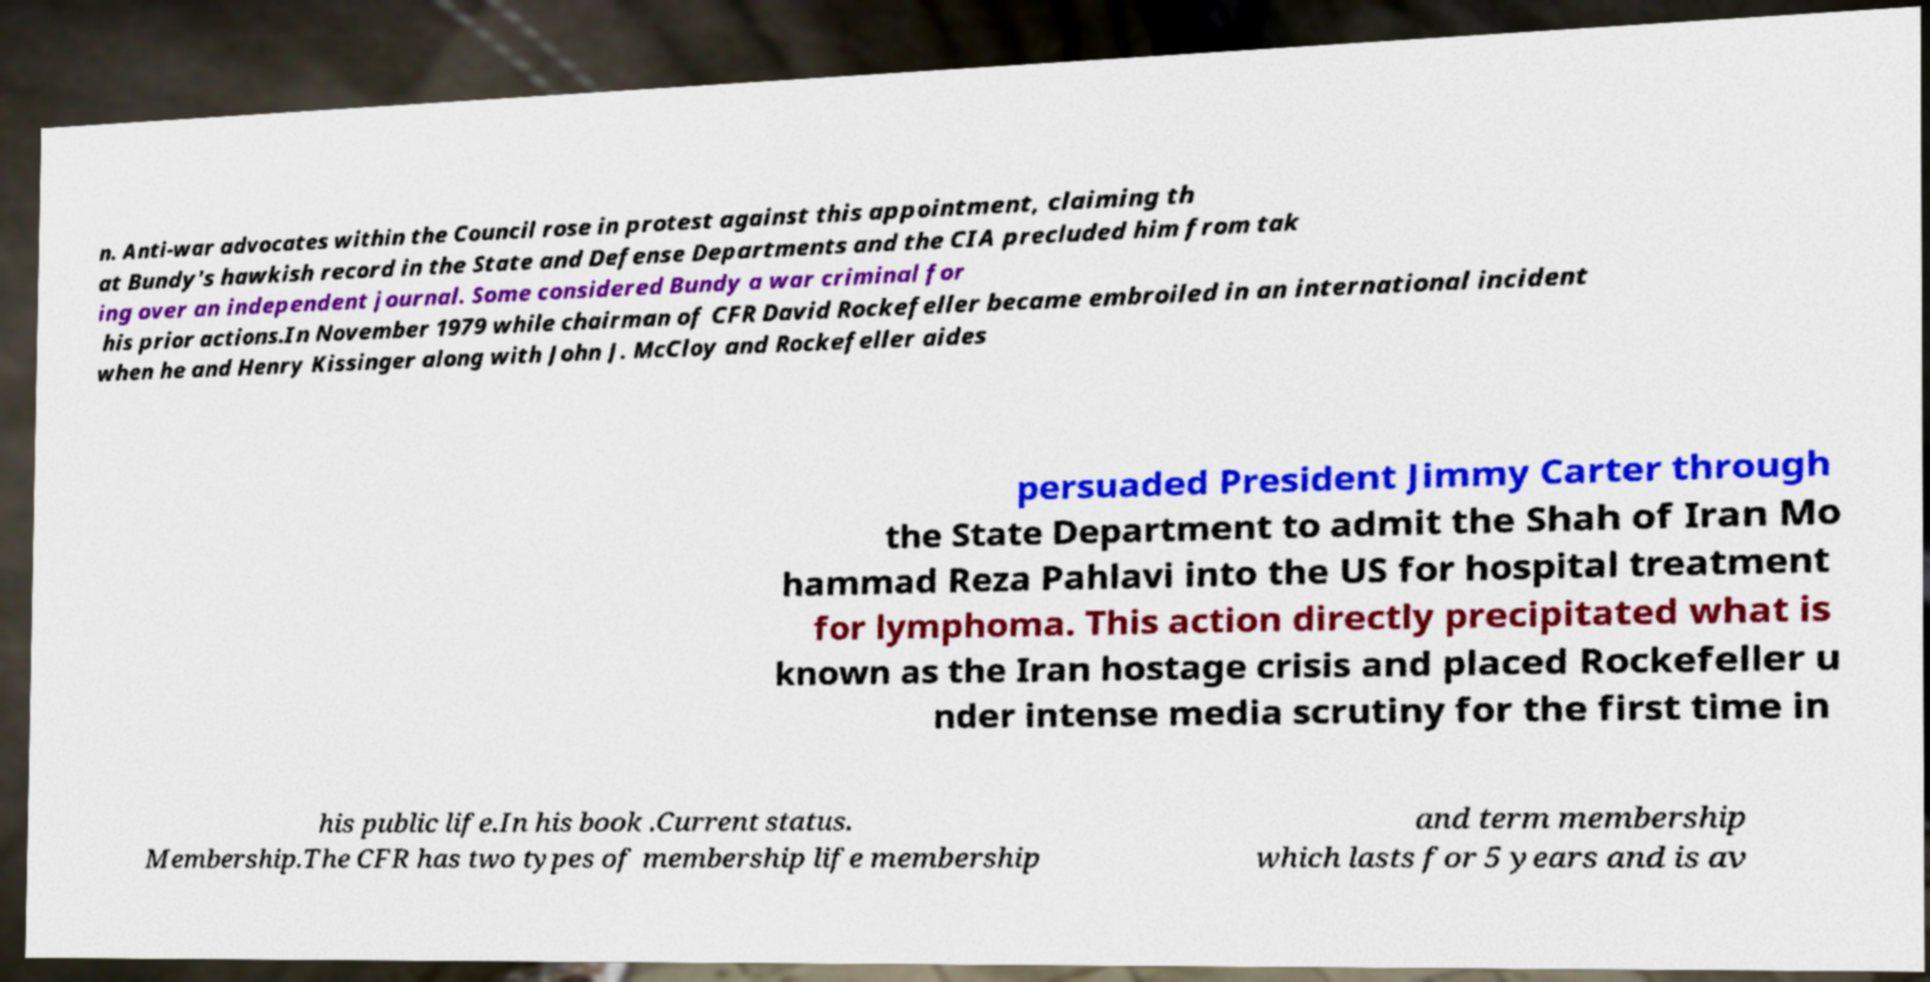Can you read and provide the text displayed in the image?This photo seems to have some interesting text. Can you extract and type it out for me? n. Anti-war advocates within the Council rose in protest against this appointment, claiming th at Bundy's hawkish record in the State and Defense Departments and the CIA precluded him from tak ing over an independent journal. Some considered Bundy a war criminal for his prior actions.In November 1979 while chairman of CFR David Rockefeller became embroiled in an international incident when he and Henry Kissinger along with John J. McCloy and Rockefeller aides persuaded President Jimmy Carter through the State Department to admit the Shah of Iran Mo hammad Reza Pahlavi into the US for hospital treatment for lymphoma. This action directly precipitated what is known as the Iran hostage crisis and placed Rockefeller u nder intense media scrutiny for the first time in his public life.In his book .Current status. Membership.The CFR has two types of membership life membership and term membership which lasts for 5 years and is av 